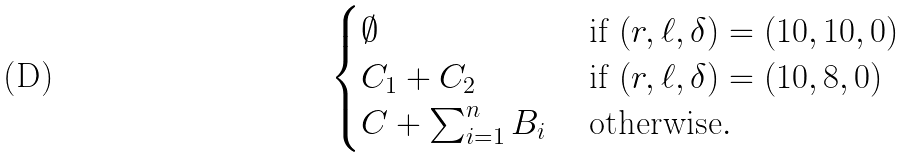<formula> <loc_0><loc_0><loc_500><loc_500>\begin{cases} \emptyset & \text { if } ( r , \ell , \delta ) = ( 1 0 , 1 0 , 0 ) \\ C _ { 1 } + C _ { 2 } & \text { if } ( r , \ell , \delta ) = ( 1 0 , 8 , 0 ) \\ C + \sum _ { i = 1 } ^ { n } B _ { i } & \text { otherwise} . \end{cases}</formula> 